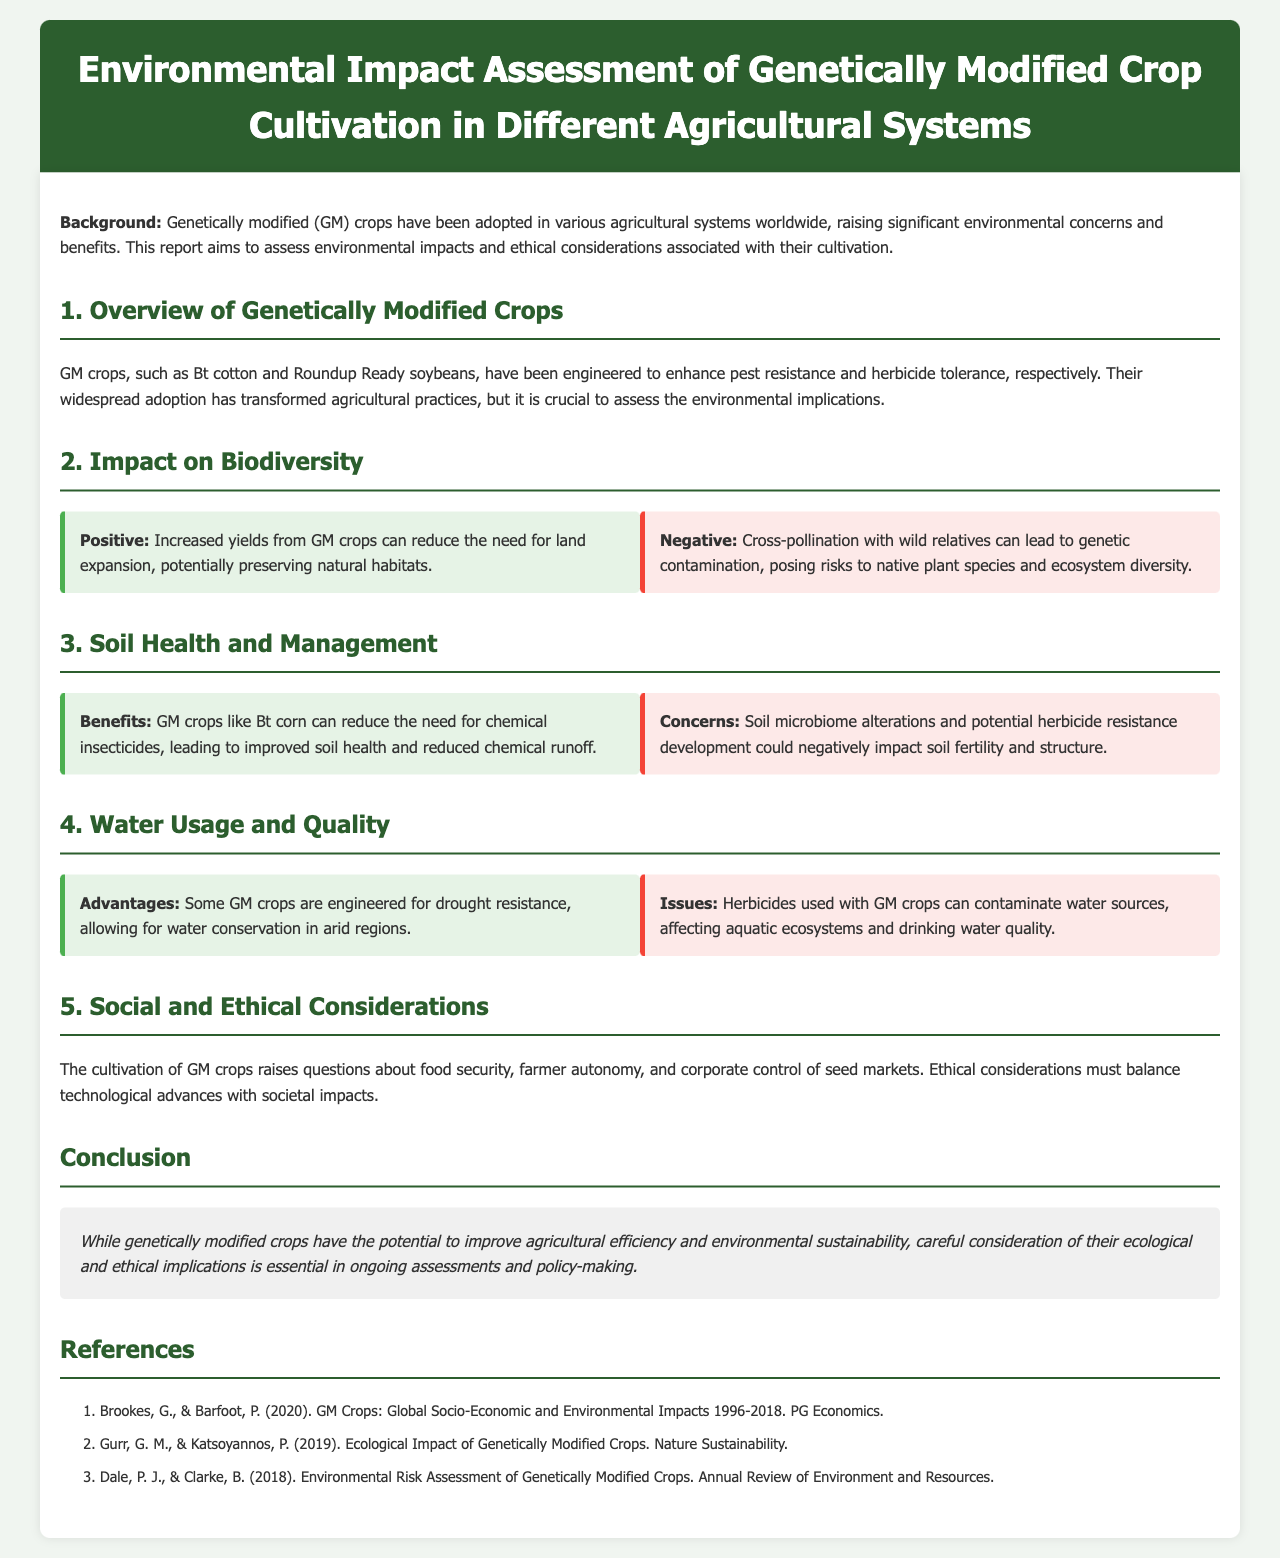What is the focus of the report? The report aims to assess environmental impacts and ethical considerations associated with genetically modified crop cultivation.
Answer: environmental impacts and ethical considerations What is a positive impact of GM crops on biodiversity? Increased yields from GM crops can reduce the need for land expansion, potentially preserving natural habitats.
Answer: preserving natural habitats What are two concerns regarding soil health when cultivating GM crops? Soil microbiome alterations and potential herbicide resistance development could negatively impact soil fertility and structure.
Answer: soil fertility and structure How do GM crops contribute to water conservation? Some GM crops are engineered for drought resistance, allowing for water conservation in arid regions.
Answer: drought resistance What ethical issues are raised by the cultivation of GM crops? The cultivation of GM crops raises questions about food security, farmer autonomy, and corporate control of seed markets.
Answer: food security, farmer autonomy, and corporate control What is the conclusion of the report regarding GM crops? While genetically modified crops have the potential to improve agricultural efficiency and environmental sustainability, careful consideration of their ecological and ethical implications is essential.
Answer: ecological and ethical implications Who are the authors of the reference discussing socio-economic impacts? Brookes and Barfoot wrote the reference about GM Crops: Global Socio-Economic and Environmental Impacts.
Answer: Brookes, G., & Barfoot, P What is the title of the second section of the report? The second section is titled “Impact on Biodiversity.”
Answer: Impact on Biodiversity What challenges are associated with herbicides used on GM crops? Herbicides used with GM crops can contaminate water sources, affecting aquatic ecosystems and drinking water quality.
Answer: water contamination 